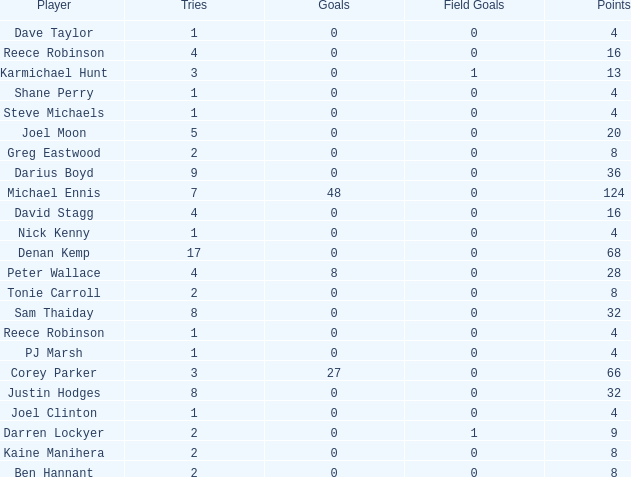How many points did the player with 2 tries and more than 0 field goals have? 9.0. 